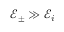Convert formula to latex. <formula><loc_0><loc_0><loc_500><loc_500>\mathcal { E } _ { \pm } \gg \mathcal { E } _ { i }</formula> 